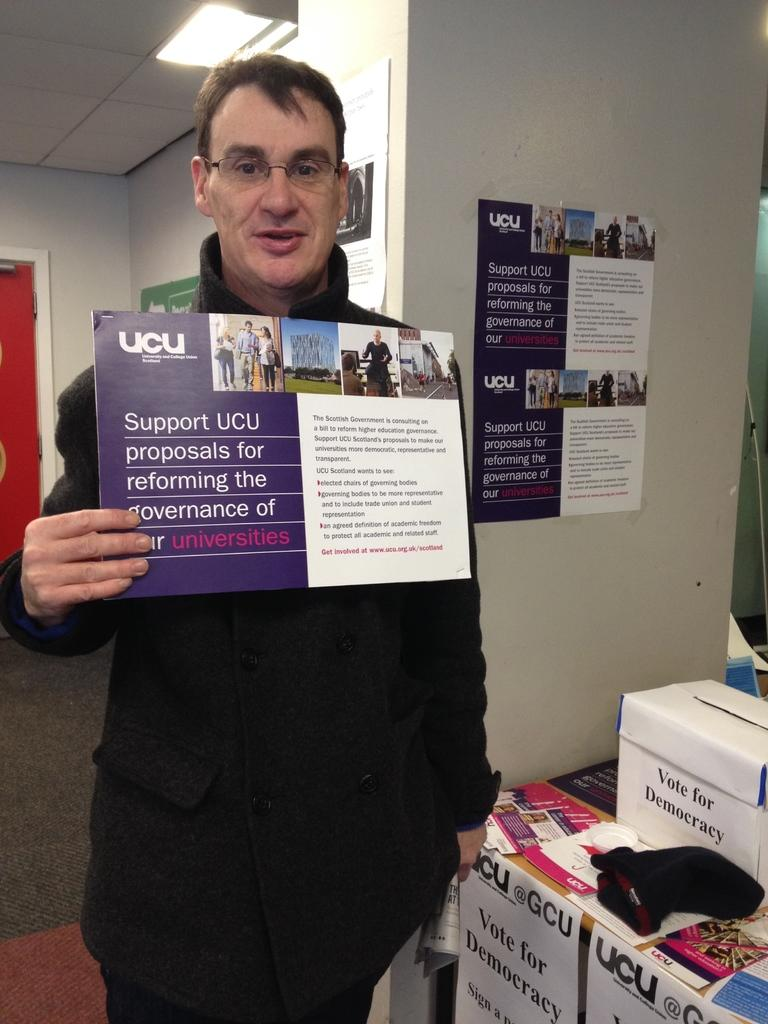<image>
Relay a brief, clear account of the picture shown. A man is holding up an ad with the UCU logo in the corner. 